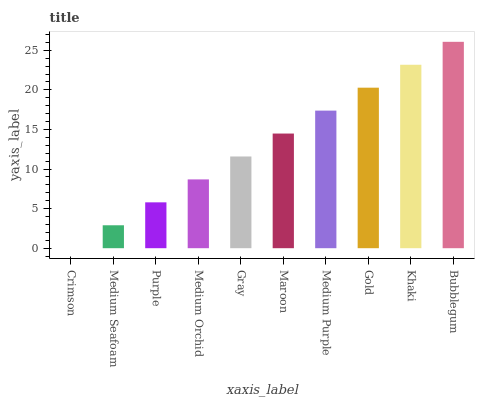Is Crimson the minimum?
Answer yes or no. Yes. Is Bubblegum the maximum?
Answer yes or no. Yes. Is Medium Seafoam the minimum?
Answer yes or no. No. Is Medium Seafoam the maximum?
Answer yes or no. No. Is Medium Seafoam greater than Crimson?
Answer yes or no. Yes. Is Crimson less than Medium Seafoam?
Answer yes or no. Yes. Is Crimson greater than Medium Seafoam?
Answer yes or no. No. Is Medium Seafoam less than Crimson?
Answer yes or no. No. Is Maroon the high median?
Answer yes or no. Yes. Is Gray the low median?
Answer yes or no. Yes. Is Medium Seafoam the high median?
Answer yes or no. No. Is Khaki the low median?
Answer yes or no. No. 